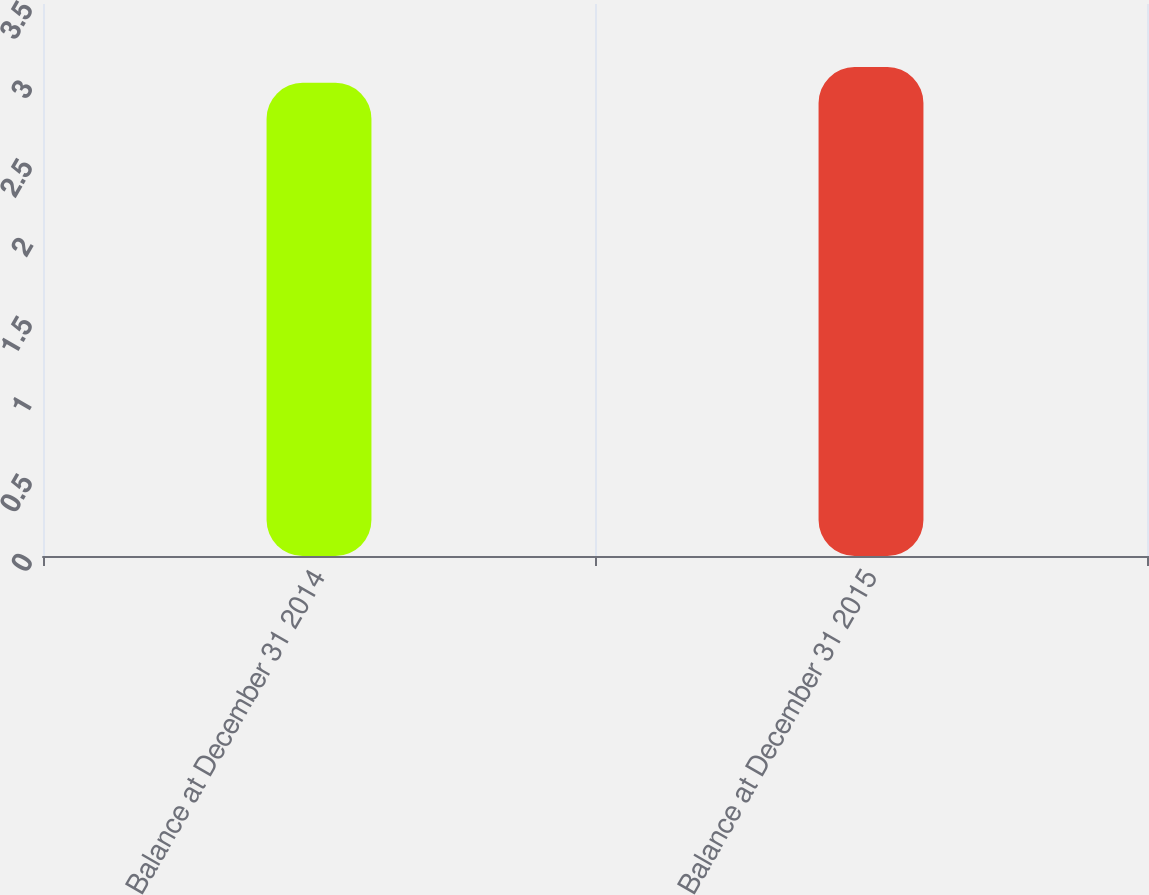Convert chart. <chart><loc_0><loc_0><loc_500><loc_500><bar_chart><fcel>Balance at December 31 2014<fcel>Balance at December 31 2015<nl><fcel>3<fcel>3.1<nl></chart> 